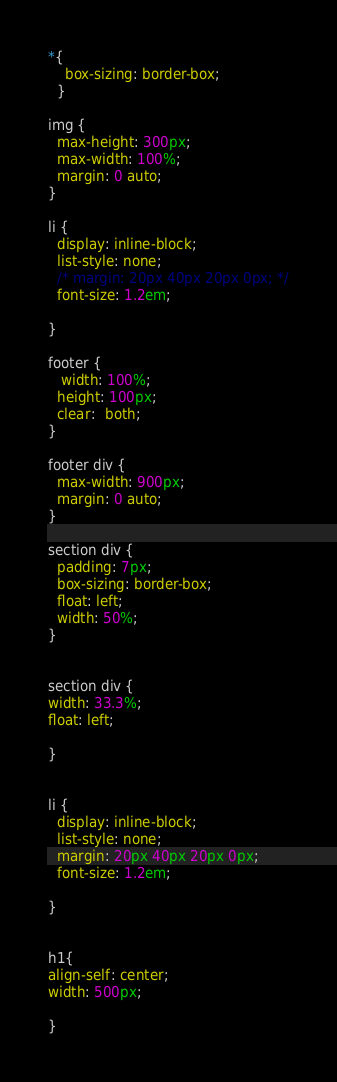Convert code to text. <code><loc_0><loc_0><loc_500><loc_500><_CSS_>*{
    box-sizing: border-box;
  }
  
img {
  max-height: 300px;
  max-width: 100%;
  margin: 0 auto;
}

li {
  display: inline-block;
  list-style: none;
  /* margin: 20px 40px 20px 0px; */
  font-size: 1.2em;
  
}

footer {
   width: 100%;
  height: 100px;
  clear:  both;
}

footer div {
  max-width: 900px;
  margin: 0 auto;
}

section div {
  padding: 7px;
  box-sizing: border-box;
  float: left;
  width: 50%;
}


section div {
width: 33.3%;
float: left;

}


li {
  display: inline-block;
  list-style: none;
  margin: 20px 40px 20px 0px;
  font-size: 1.2em;
  
}


h1{
align-self: center;
width: 500px;

}</code> 